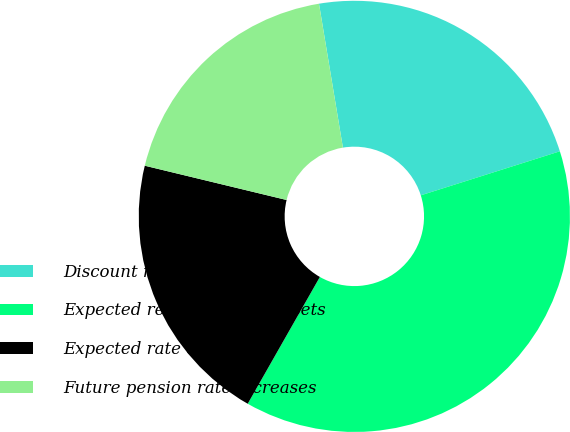Convert chart to OTSL. <chart><loc_0><loc_0><loc_500><loc_500><pie_chart><fcel>Discount rate<fcel>Expected return on plan assets<fcel>Expected rate of salary<fcel>Future pension rate increases<nl><fcel>22.74%<fcel>38.11%<fcel>20.54%<fcel>18.6%<nl></chart> 